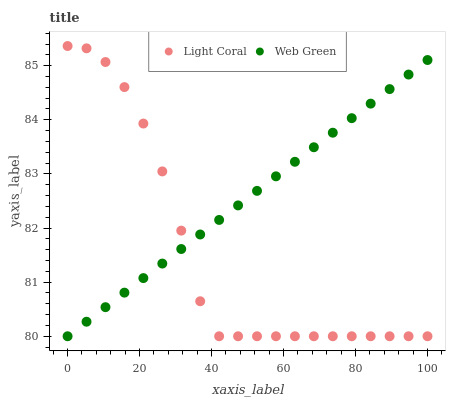Does Light Coral have the minimum area under the curve?
Answer yes or no. Yes. Does Web Green have the maximum area under the curve?
Answer yes or no. Yes. Does Web Green have the minimum area under the curve?
Answer yes or no. No. Is Web Green the smoothest?
Answer yes or no. Yes. Is Light Coral the roughest?
Answer yes or no. Yes. Is Web Green the roughest?
Answer yes or no. No. Does Light Coral have the lowest value?
Answer yes or no. Yes. Does Light Coral have the highest value?
Answer yes or no. Yes. Does Web Green have the highest value?
Answer yes or no. No. Does Light Coral intersect Web Green?
Answer yes or no. Yes. Is Light Coral less than Web Green?
Answer yes or no. No. Is Light Coral greater than Web Green?
Answer yes or no. No. 